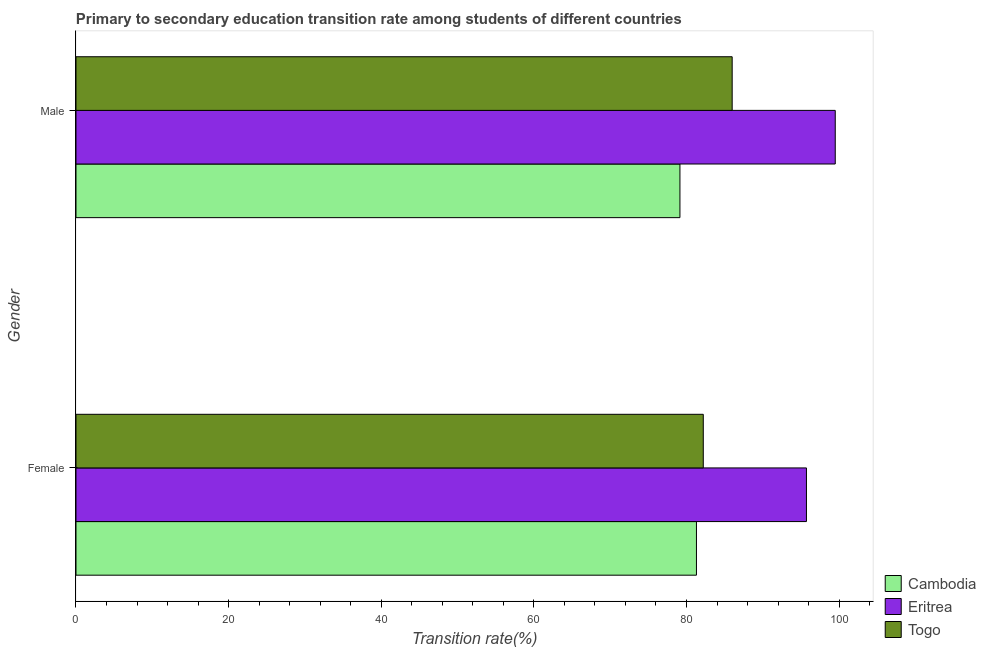How many groups of bars are there?
Give a very brief answer. 2. Are the number of bars per tick equal to the number of legend labels?
Ensure brevity in your answer.  Yes. How many bars are there on the 1st tick from the top?
Your response must be concise. 3. How many bars are there on the 1st tick from the bottom?
Provide a short and direct response. 3. What is the transition rate among male students in Eritrea?
Your answer should be compact. 99.5. Across all countries, what is the maximum transition rate among male students?
Ensure brevity in your answer.  99.5. Across all countries, what is the minimum transition rate among male students?
Your answer should be very brief. 79.14. In which country was the transition rate among female students maximum?
Provide a succinct answer. Eritrea. In which country was the transition rate among female students minimum?
Ensure brevity in your answer.  Cambodia. What is the total transition rate among female students in the graph?
Your answer should be very brief. 259.23. What is the difference between the transition rate among female students in Togo and that in Cambodia?
Provide a short and direct response. 0.89. What is the difference between the transition rate among male students in Togo and the transition rate among female students in Eritrea?
Give a very brief answer. -9.73. What is the average transition rate among female students per country?
Give a very brief answer. 86.41. What is the difference between the transition rate among female students and transition rate among male students in Cambodia?
Provide a short and direct response. 2.17. In how many countries, is the transition rate among male students greater than 92 %?
Provide a succinct answer. 1. What is the ratio of the transition rate among female students in Eritrea to that in Cambodia?
Your answer should be compact. 1.18. Is the transition rate among female students in Togo less than that in Cambodia?
Ensure brevity in your answer.  No. In how many countries, is the transition rate among female students greater than the average transition rate among female students taken over all countries?
Make the answer very short. 1. What does the 3rd bar from the top in Female represents?
Your answer should be very brief. Cambodia. What does the 1st bar from the bottom in Female represents?
Offer a terse response. Cambodia. Are all the bars in the graph horizontal?
Your answer should be compact. Yes. What is the difference between two consecutive major ticks on the X-axis?
Your response must be concise. 20. Does the graph contain any zero values?
Keep it short and to the point. No. What is the title of the graph?
Your answer should be very brief. Primary to secondary education transition rate among students of different countries. Does "Micronesia" appear as one of the legend labels in the graph?
Give a very brief answer. No. What is the label or title of the X-axis?
Offer a terse response. Transition rate(%). What is the label or title of the Y-axis?
Keep it short and to the point. Gender. What is the Transition rate(%) of Cambodia in Female?
Your response must be concise. 81.31. What is the Transition rate(%) in Eritrea in Female?
Give a very brief answer. 95.72. What is the Transition rate(%) of Togo in Female?
Ensure brevity in your answer.  82.2. What is the Transition rate(%) in Cambodia in Male?
Provide a succinct answer. 79.14. What is the Transition rate(%) in Eritrea in Male?
Offer a very short reply. 99.5. What is the Transition rate(%) of Togo in Male?
Offer a very short reply. 85.99. Across all Gender, what is the maximum Transition rate(%) of Cambodia?
Offer a terse response. 81.31. Across all Gender, what is the maximum Transition rate(%) of Eritrea?
Provide a succinct answer. 99.5. Across all Gender, what is the maximum Transition rate(%) of Togo?
Your answer should be compact. 85.99. Across all Gender, what is the minimum Transition rate(%) of Cambodia?
Your answer should be compact. 79.14. Across all Gender, what is the minimum Transition rate(%) of Eritrea?
Offer a terse response. 95.72. Across all Gender, what is the minimum Transition rate(%) in Togo?
Make the answer very short. 82.2. What is the total Transition rate(%) of Cambodia in the graph?
Provide a short and direct response. 160.45. What is the total Transition rate(%) of Eritrea in the graph?
Provide a short and direct response. 195.22. What is the total Transition rate(%) of Togo in the graph?
Offer a terse response. 168.19. What is the difference between the Transition rate(%) of Cambodia in Female and that in Male?
Give a very brief answer. 2.17. What is the difference between the Transition rate(%) of Eritrea in Female and that in Male?
Provide a short and direct response. -3.77. What is the difference between the Transition rate(%) of Togo in Female and that in Male?
Make the answer very short. -3.79. What is the difference between the Transition rate(%) in Cambodia in Female and the Transition rate(%) in Eritrea in Male?
Keep it short and to the point. -18.19. What is the difference between the Transition rate(%) of Cambodia in Female and the Transition rate(%) of Togo in Male?
Your answer should be very brief. -4.68. What is the difference between the Transition rate(%) in Eritrea in Female and the Transition rate(%) in Togo in Male?
Your response must be concise. 9.73. What is the average Transition rate(%) of Cambodia per Gender?
Ensure brevity in your answer.  80.23. What is the average Transition rate(%) in Eritrea per Gender?
Ensure brevity in your answer.  97.61. What is the average Transition rate(%) of Togo per Gender?
Ensure brevity in your answer.  84.1. What is the difference between the Transition rate(%) of Cambodia and Transition rate(%) of Eritrea in Female?
Keep it short and to the point. -14.41. What is the difference between the Transition rate(%) in Cambodia and Transition rate(%) in Togo in Female?
Make the answer very short. -0.89. What is the difference between the Transition rate(%) in Eritrea and Transition rate(%) in Togo in Female?
Keep it short and to the point. 13.52. What is the difference between the Transition rate(%) of Cambodia and Transition rate(%) of Eritrea in Male?
Give a very brief answer. -20.35. What is the difference between the Transition rate(%) in Cambodia and Transition rate(%) in Togo in Male?
Ensure brevity in your answer.  -6.85. What is the difference between the Transition rate(%) of Eritrea and Transition rate(%) of Togo in Male?
Offer a very short reply. 13.51. What is the ratio of the Transition rate(%) in Cambodia in Female to that in Male?
Your answer should be compact. 1.03. What is the ratio of the Transition rate(%) of Eritrea in Female to that in Male?
Ensure brevity in your answer.  0.96. What is the ratio of the Transition rate(%) in Togo in Female to that in Male?
Make the answer very short. 0.96. What is the difference between the highest and the second highest Transition rate(%) in Cambodia?
Keep it short and to the point. 2.17. What is the difference between the highest and the second highest Transition rate(%) of Eritrea?
Make the answer very short. 3.77. What is the difference between the highest and the second highest Transition rate(%) in Togo?
Keep it short and to the point. 3.79. What is the difference between the highest and the lowest Transition rate(%) in Cambodia?
Your response must be concise. 2.17. What is the difference between the highest and the lowest Transition rate(%) in Eritrea?
Your answer should be very brief. 3.77. What is the difference between the highest and the lowest Transition rate(%) of Togo?
Make the answer very short. 3.79. 